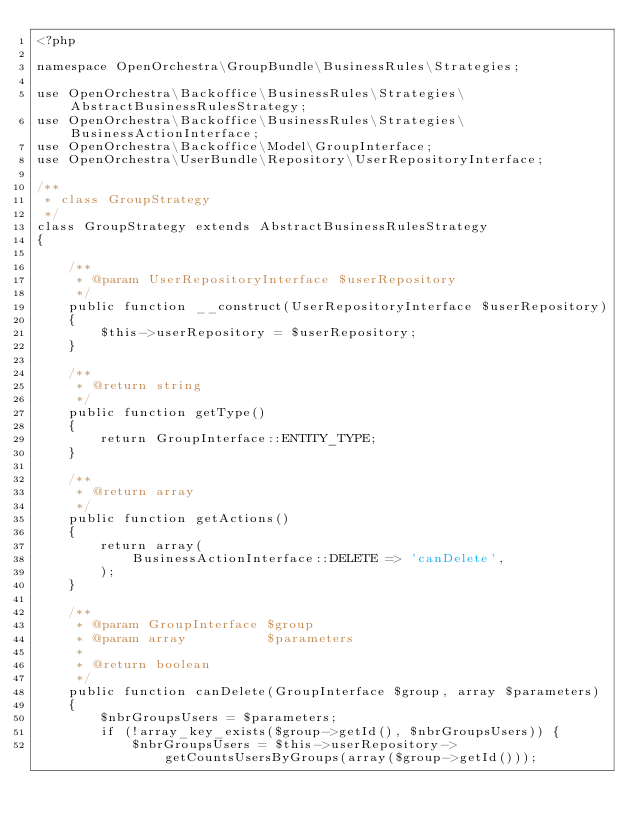<code> <loc_0><loc_0><loc_500><loc_500><_PHP_><?php

namespace OpenOrchestra\GroupBundle\BusinessRules\Strategies;

use OpenOrchestra\Backoffice\BusinessRules\Strategies\AbstractBusinessRulesStrategy;
use OpenOrchestra\Backoffice\BusinessRules\Strategies\BusinessActionInterface;
use OpenOrchestra\Backoffice\Model\GroupInterface;
use OpenOrchestra\UserBundle\Repository\UserRepositoryInterface;

/**
 * class GroupStrategy
 */
class GroupStrategy extends AbstractBusinessRulesStrategy
{

    /**
     * @param UserRepositoryInterface $userRepository
     */
    public function __construct(UserRepositoryInterface $userRepository)
    {
        $this->userRepository = $userRepository;
    }

    /**
     * @return string
     */
    public function getType()
    {
        return GroupInterface::ENTITY_TYPE;
    }

    /**
     * @return array
     */
    public function getActions()
    {
        return array(
            BusinessActionInterface::DELETE => 'canDelete',
        );
    }

    /**
     * @param GroupInterface $group
     * @param array          $parameters
     *
     * @return boolean
     */
    public function canDelete(GroupInterface $group, array $parameters)
    {
        $nbrGroupsUsers = $parameters;
        if (!array_key_exists($group->getId(), $nbrGroupsUsers)) {
            $nbrGroupsUsers = $this->userRepository->getCountsUsersByGroups(array($group->getId()));</code> 